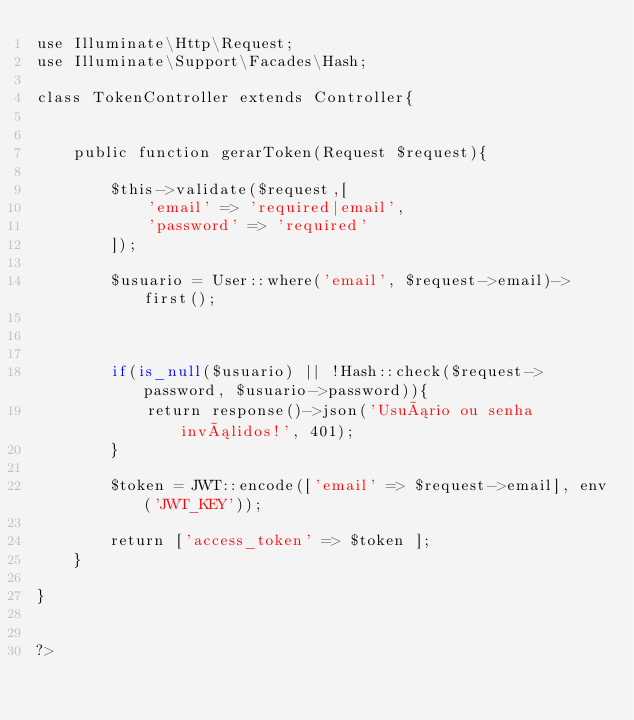Convert code to text. <code><loc_0><loc_0><loc_500><loc_500><_PHP_>use Illuminate\Http\Request;
use Illuminate\Support\Facades\Hash;

class TokenController extends Controller{

    
    public function gerarToken(Request $request){

        $this->validate($request,[
            'email' => 'required|email',
            'password' => 'required'
        ]);

        $usuario = User::where('email', $request->email)->first();

        

        if(is_null($usuario) || !Hash::check($request->password, $usuario->password)){
            return response()->json('Usuário ou senha inválidos!', 401);
        }

        $token = JWT::encode(['email' => $request->email], env('JWT_KEY'));

        return ['access_token' => $token ];
    }

}


?></code> 